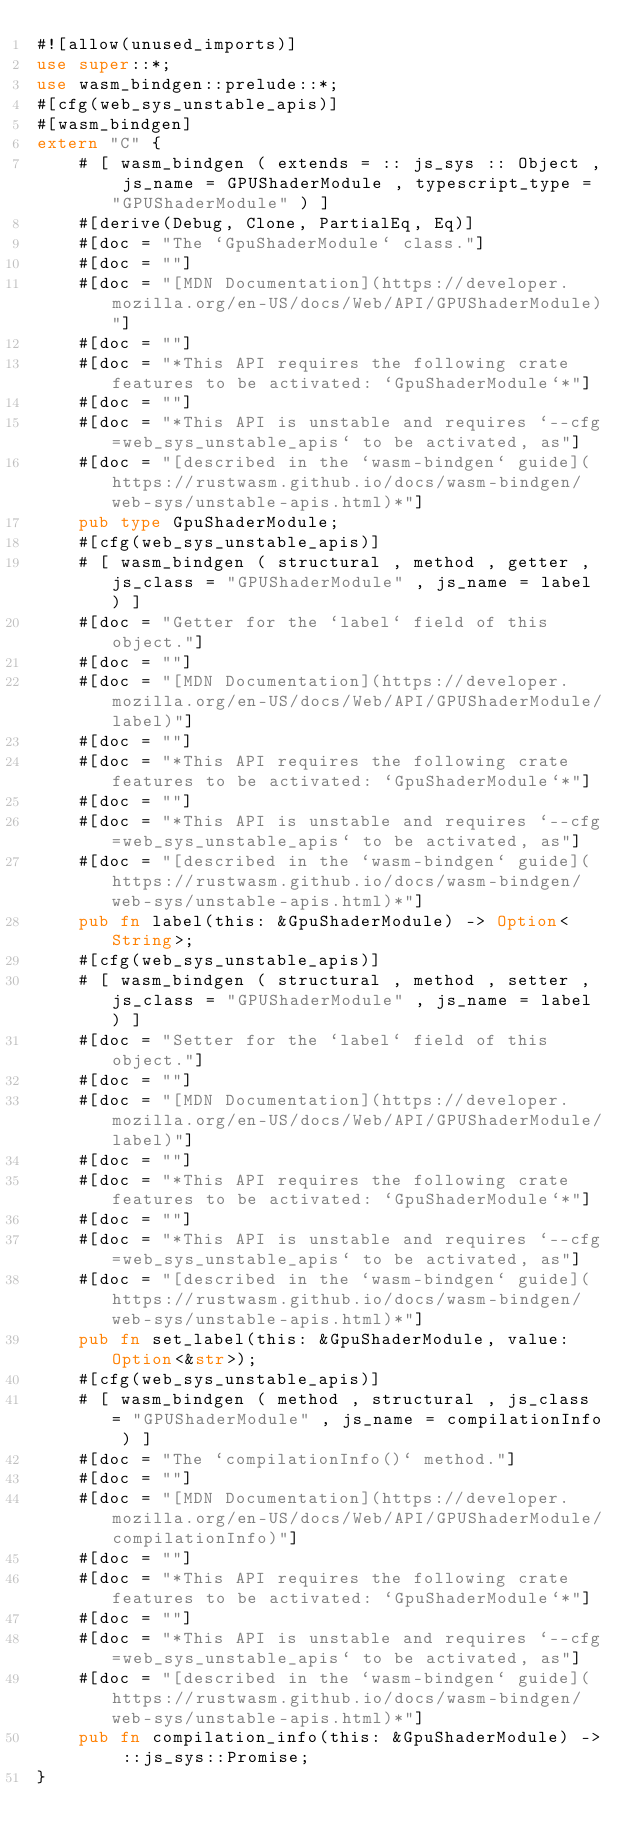Convert code to text. <code><loc_0><loc_0><loc_500><loc_500><_Rust_>#![allow(unused_imports)]
use super::*;
use wasm_bindgen::prelude::*;
#[cfg(web_sys_unstable_apis)]
#[wasm_bindgen]
extern "C" {
    # [ wasm_bindgen ( extends = :: js_sys :: Object , js_name = GPUShaderModule , typescript_type = "GPUShaderModule" ) ]
    #[derive(Debug, Clone, PartialEq, Eq)]
    #[doc = "The `GpuShaderModule` class."]
    #[doc = ""]
    #[doc = "[MDN Documentation](https://developer.mozilla.org/en-US/docs/Web/API/GPUShaderModule)"]
    #[doc = ""]
    #[doc = "*This API requires the following crate features to be activated: `GpuShaderModule`*"]
    #[doc = ""]
    #[doc = "*This API is unstable and requires `--cfg=web_sys_unstable_apis` to be activated, as"]
    #[doc = "[described in the `wasm-bindgen` guide](https://rustwasm.github.io/docs/wasm-bindgen/web-sys/unstable-apis.html)*"]
    pub type GpuShaderModule;
    #[cfg(web_sys_unstable_apis)]
    # [ wasm_bindgen ( structural , method , getter , js_class = "GPUShaderModule" , js_name = label ) ]
    #[doc = "Getter for the `label` field of this object."]
    #[doc = ""]
    #[doc = "[MDN Documentation](https://developer.mozilla.org/en-US/docs/Web/API/GPUShaderModule/label)"]
    #[doc = ""]
    #[doc = "*This API requires the following crate features to be activated: `GpuShaderModule`*"]
    #[doc = ""]
    #[doc = "*This API is unstable and requires `--cfg=web_sys_unstable_apis` to be activated, as"]
    #[doc = "[described in the `wasm-bindgen` guide](https://rustwasm.github.io/docs/wasm-bindgen/web-sys/unstable-apis.html)*"]
    pub fn label(this: &GpuShaderModule) -> Option<String>;
    #[cfg(web_sys_unstable_apis)]
    # [ wasm_bindgen ( structural , method , setter , js_class = "GPUShaderModule" , js_name = label ) ]
    #[doc = "Setter for the `label` field of this object."]
    #[doc = ""]
    #[doc = "[MDN Documentation](https://developer.mozilla.org/en-US/docs/Web/API/GPUShaderModule/label)"]
    #[doc = ""]
    #[doc = "*This API requires the following crate features to be activated: `GpuShaderModule`*"]
    #[doc = ""]
    #[doc = "*This API is unstable and requires `--cfg=web_sys_unstable_apis` to be activated, as"]
    #[doc = "[described in the `wasm-bindgen` guide](https://rustwasm.github.io/docs/wasm-bindgen/web-sys/unstable-apis.html)*"]
    pub fn set_label(this: &GpuShaderModule, value: Option<&str>);
    #[cfg(web_sys_unstable_apis)]
    # [ wasm_bindgen ( method , structural , js_class = "GPUShaderModule" , js_name = compilationInfo ) ]
    #[doc = "The `compilationInfo()` method."]
    #[doc = ""]
    #[doc = "[MDN Documentation](https://developer.mozilla.org/en-US/docs/Web/API/GPUShaderModule/compilationInfo)"]
    #[doc = ""]
    #[doc = "*This API requires the following crate features to be activated: `GpuShaderModule`*"]
    #[doc = ""]
    #[doc = "*This API is unstable and requires `--cfg=web_sys_unstable_apis` to be activated, as"]
    #[doc = "[described in the `wasm-bindgen` guide](https://rustwasm.github.io/docs/wasm-bindgen/web-sys/unstable-apis.html)*"]
    pub fn compilation_info(this: &GpuShaderModule) -> ::js_sys::Promise;
}
</code> 